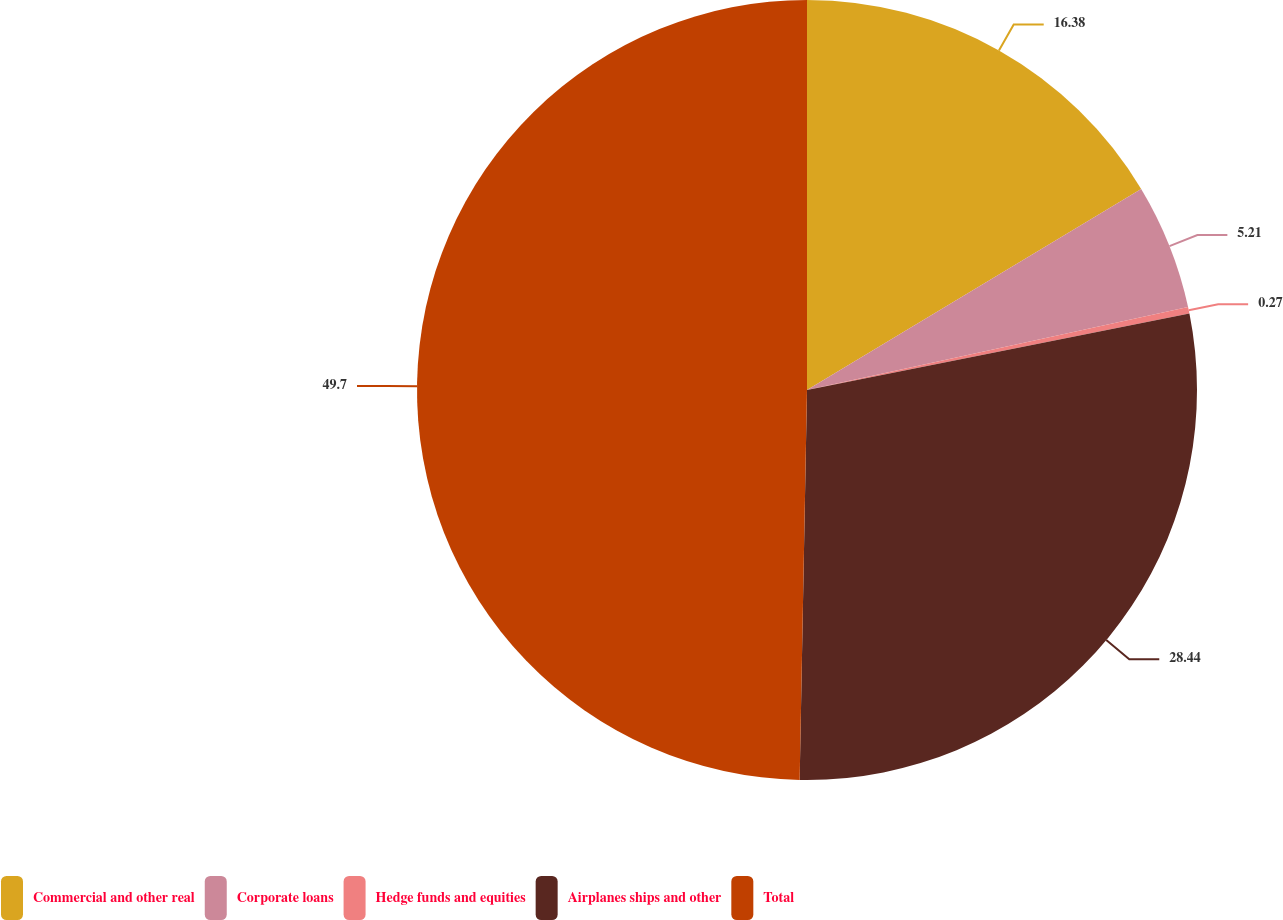Convert chart to OTSL. <chart><loc_0><loc_0><loc_500><loc_500><pie_chart><fcel>Commercial and other real<fcel>Corporate loans<fcel>Hedge funds and equities<fcel>Airplanes ships and other<fcel>Total<nl><fcel>16.38%<fcel>5.21%<fcel>0.27%<fcel>28.44%<fcel>49.7%<nl></chart> 